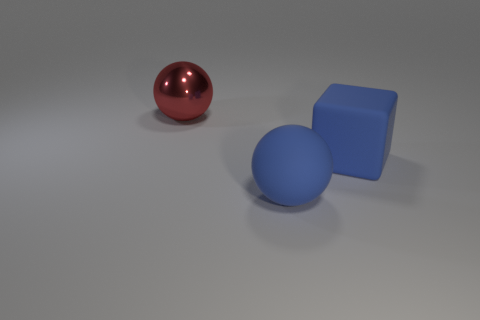How many red metal things are in front of the red sphere that is behind the large blue thing that is to the right of the large matte sphere? Analyzing the image, there are no red metal objects in front of the red sphere. The area in front of this sphere is clear, with the red sphere itself being the most prominent object in its immediate vicinity. 